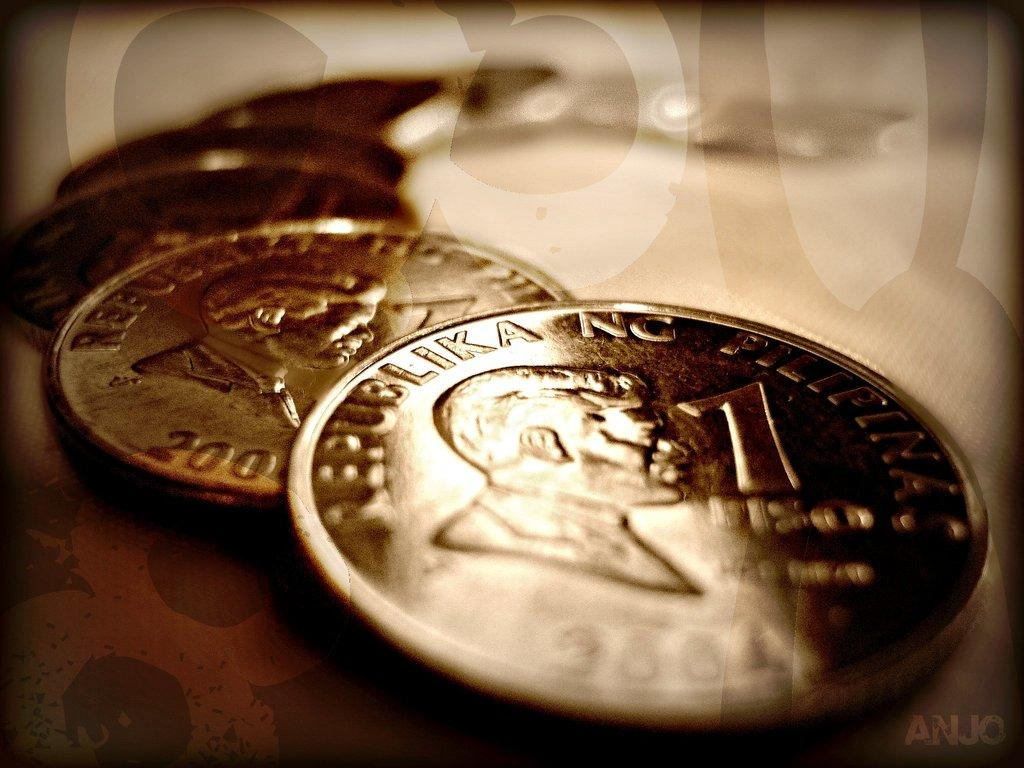<image>
Summarize the visual content of the image. A collection of coins is lined up, and the front two are worth one each. 